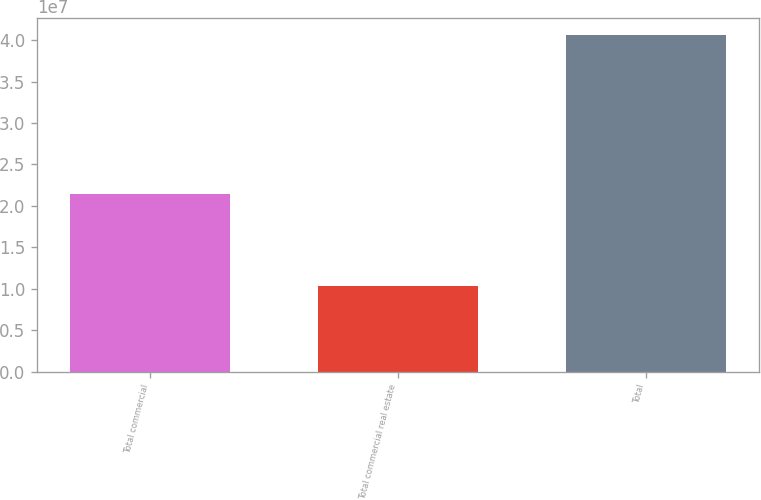Convert chart to OTSL. <chart><loc_0><loc_0><loc_500><loc_500><bar_chart><fcel>Total commercial<fcel>Total commercial real estate<fcel>Total<nl><fcel>2.1479e+07<fcel>1.03559e+07<fcel>4.06495e+07<nl></chart> 